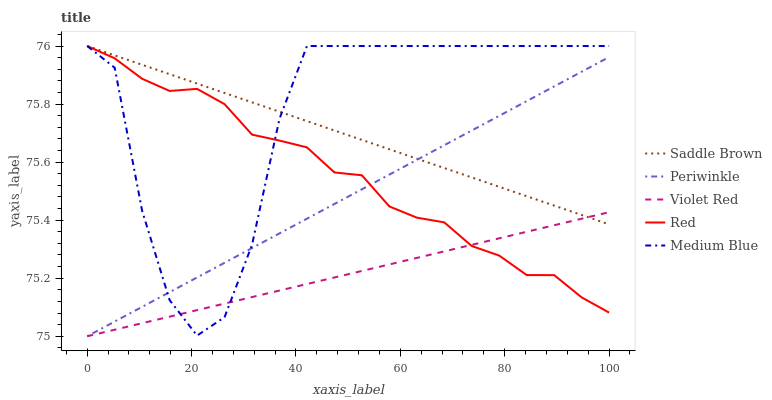Does Periwinkle have the minimum area under the curve?
Answer yes or no. No. Does Periwinkle have the maximum area under the curve?
Answer yes or no. No. Is Violet Red the smoothest?
Answer yes or no. No. Is Violet Red the roughest?
Answer yes or no. No. Does Saddle Brown have the lowest value?
Answer yes or no. No. Does Periwinkle have the highest value?
Answer yes or no. No. 